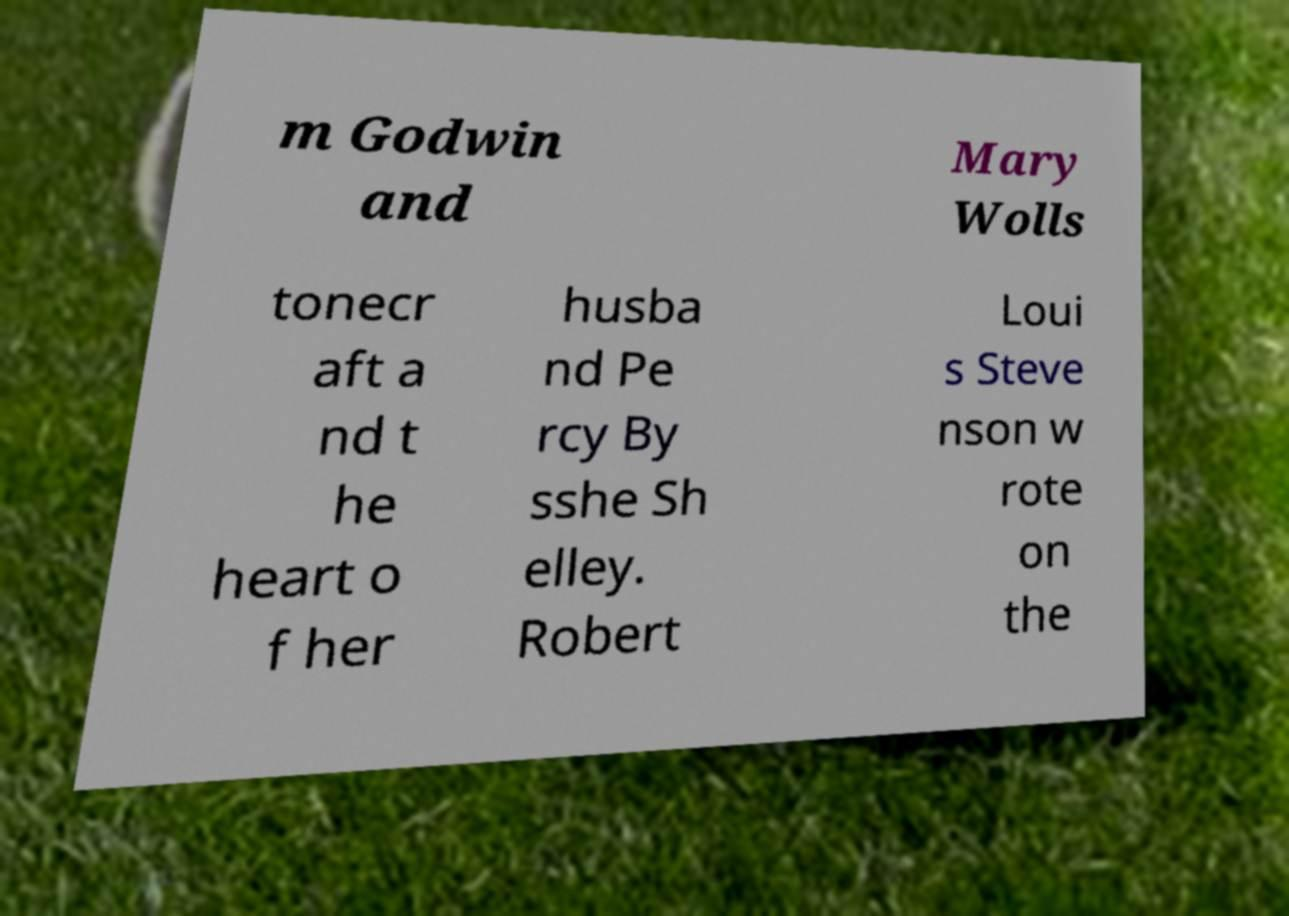What messages or text are displayed in this image? I need them in a readable, typed format. m Godwin and Mary Wolls tonecr aft a nd t he heart o f her husba nd Pe rcy By sshe Sh elley. Robert Loui s Steve nson w rote on the 